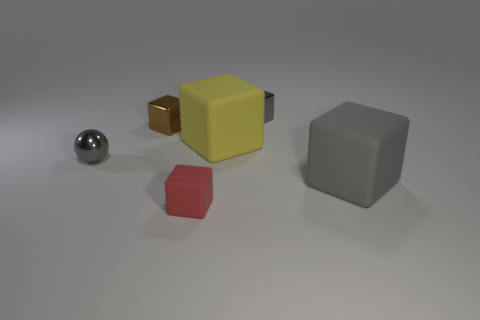Subtract all large gray cubes. How many cubes are left? 4 Add 1 small red matte objects. How many objects exist? 7 Subtract all gray cubes. How many cubes are left? 3 Subtract all cubes. How many objects are left? 1 Add 2 small objects. How many small objects are left? 6 Add 3 red rubber blocks. How many red rubber blocks exist? 4 Subtract 0 blue cylinders. How many objects are left? 6 Subtract 1 cubes. How many cubes are left? 4 Subtract all green spheres. Subtract all cyan blocks. How many spheres are left? 1 Subtract all purple cylinders. How many gray blocks are left? 2 